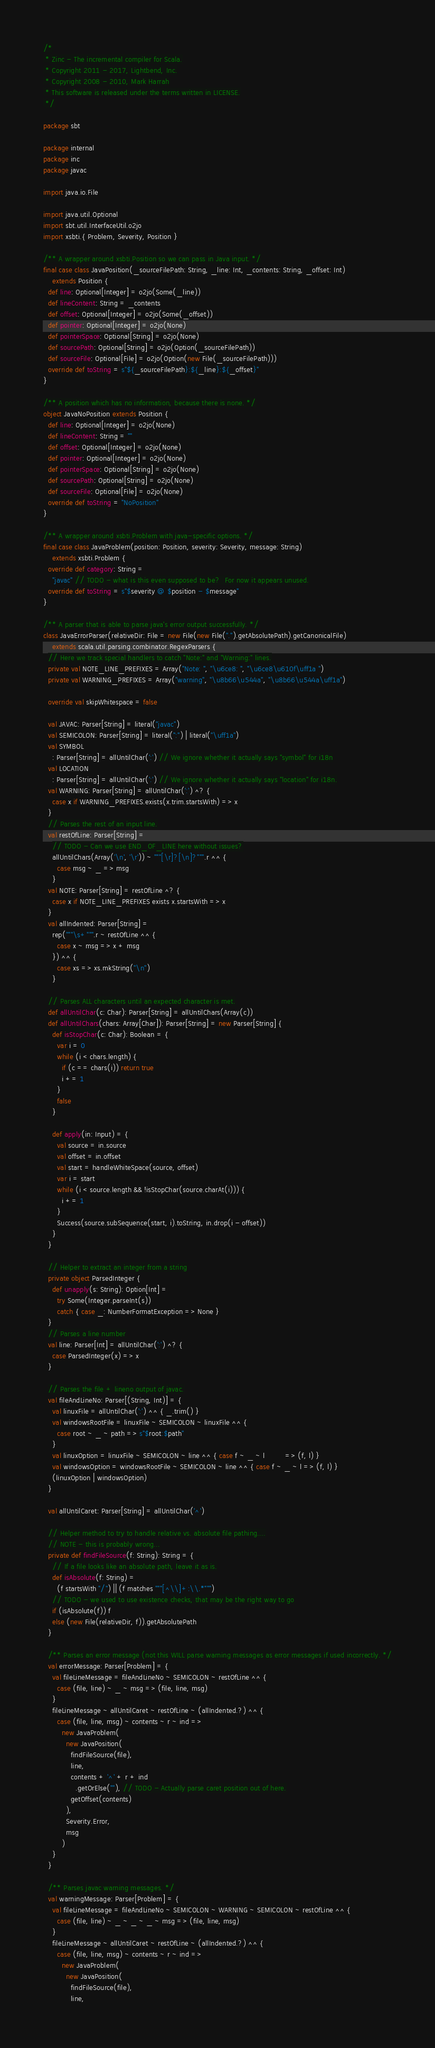<code> <loc_0><loc_0><loc_500><loc_500><_Scala_>/*
 * Zinc - The incremental compiler for Scala.
 * Copyright 2011 - 2017, Lightbend, Inc.
 * Copyright 2008 - 2010, Mark Harrah
 * This software is released under the terms written in LICENSE.
 */

package sbt

package internal
package inc
package javac

import java.io.File

import java.util.Optional
import sbt.util.InterfaceUtil.o2jo
import xsbti.{ Problem, Severity, Position }

/** A wrapper around xsbti.Position so we can pass in Java input. */
final case class JavaPosition(_sourceFilePath: String, _line: Int, _contents: String, _offset: Int)
    extends Position {
  def line: Optional[Integer] = o2jo(Some(_line))
  def lineContent: String = _contents
  def offset: Optional[Integer] = o2jo(Some(_offset))
  def pointer: Optional[Integer] = o2jo(None)
  def pointerSpace: Optional[String] = o2jo(None)
  def sourcePath: Optional[String] = o2jo(Option(_sourceFilePath))
  def sourceFile: Optional[File] = o2jo(Option(new File(_sourceFilePath)))
  override def toString = s"${_sourceFilePath}:${_line}:${_offset}"
}

/** A position which has no information, because there is none. */
object JavaNoPosition extends Position {
  def line: Optional[Integer] = o2jo(None)
  def lineContent: String = ""
  def offset: Optional[Integer] = o2jo(None)
  def pointer: Optional[Integer] = o2jo(None)
  def pointerSpace: Optional[String] = o2jo(None)
  def sourcePath: Optional[String] = o2jo(None)
  def sourceFile: Optional[File] = o2jo(None)
  override def toString = "NoPosition"
}

/** A wrapper around xsbti.Problem with java-specific options. */
final case class JavaProblem(position: Position, severity: Severity, message: String)
    extends xsbti.Problem {
  override def category: String =
    "javac" // TODO - what is this even supposed to be?  For now it appears unused.
  override def toString = s"$severity @ $position - $message"
}

/** A parser that is able to parse java's error output successfully. */
class JavaErrorParser(relativeDir: File = new File(new File(".").getAbsolutePath).getCanonicalFile)
    extends scala.util.parsing.combinator.RegexParsers {
  // Here we track special handlers to catch "Note:" and "Warning:" lines.
  private val NOTE_LINE_PREFIXES = Array("Note: ", "\u6ce8: ", "\u6ce8\u610f\uff1a ")
  private val WARNING_PREFIXES = Array("warning", "\u8b66\u544a", "\u8b66\u544a\uff1a")

  override val skipWhitespace = false

  val JAVAC: Parser[String] = literal("javac")
  val SEMICOLON: Parser[String] = literal(":") | literal("\uff1a")
  val SYMBOL
    : Parser[String] = allUntilChar(':') // We ignore whether it actually says "symbol" for i18n
  val LOCATION
    : Parser[String] = allUntilChar(':') // We ignore whether it actually says "location" for i18n.
  val WARNING: Parser[String] = allUntilChar(':') ^? {
    case x if WARNING_PREFIXES.exists(x.trim.startsWith) => x
  }
  // Parses the rest of an input line.
  val restOfLine: Parser[String] =
    // TODO - Can we use END_OF_LINE here without issues?
    allUntilChars(Array('\n', '\r')) ~ """[\r]?[\n]?""".r ^^ {
      case msg ~ _ => msg
    }
  val NOTE: Parser[String] = restOfLine ^? {
    case x if NOTE_LINE_PREFIXES exists x.startsWith => x
  }
  val allIndented: Parser[String] =
    rep("""\s+""".r ~ restOfLine ^^ {
      case x ~ msg => x + msg
    }) ^^ {
      case xs => xs.mkString("\n")
    }

  // Parses ALL characters until an expected character is met.
  def allUntilChar(c: Char): Parser[String] = allUntilChars(Array(c))
  def allUntilChars(chars: Array[Char]): Parser[String] = new Parser[String] {
    def isStopChar(c: Char): Boolean = {
      var i = 0
      while (i < chars.length) {
        if (c == chars(i)) return true
        i += 1
      }
      false
    }

    def apply(in: Input) = {
      val source = in.source
      val offset = in.offset
      val start = handleWhiteSpace(source, offset)
      var i = start
      while (i < source.length && !isStopChar(source.charAt(i))) {
        i += 1
      }
      Success(source.subSequence(start, i).toString, in.drop(i - offset))
    }
  }

  // Helper to extract an integer from a string
  private object ParsedInteger {
    def unapply(s: String): Option[Int] =
      try Some(Integer.parseInt(s))
      catch { case _: NumberFormatException => None }
  }
  // Parses a line number
  val line: Parser[Int] = allUntilChar(':') ^? {
    case ParsedInteger(x) => x
  }

  // Parses the file + lineno output of javac.
  val fileAndLineNo: Parser[(String, Int)] = {
    val linuxFile = allUntilChar(':') ^^ { _.trim() }
    val windowsRootFile = linuxFile ~ SEMICOLON ~ linuxFile ^^ {
      case root ~ _ ~ path => s"$root:$path"
    }
    val linuxOption = linuxFile ~ SEMICOLON ~ line ^^ { case f ~ _ ~ l         => (f, l) }
    val windowsOption = windowsRootFile ~ SEMICOLON ~ line ^^ { case f ~ _ ~ l => (f, l) }
    (linuxOption | windowsOption)
  }

  val allUntilCaret: Parser[String] = allUntilChar('^')

  // Helper method to try to handle relative vs. absolute file pathing....
  // NOTE - this is probably wrong...
  private def findFileSource(f: String): String = {
    // If a file looks like an absolute path, leave it as is.
    def isAbsolute(f: String) =
      (f startsWith "/") || (f matches """[^\\]+:\\.*""")
    // TODO - we used to use existence checks, that may be the right way to go
    if (isAbsolute(f)) f
    else (new File(relativeDir, f)).getAbsolutePath
  }

  /** Parses an error message (not this WILL parse warning messages as error messages if used incorrectly. */
  val errorMessage: Parser[Problem] = {
    val fileLineMessage = fileAndLineNo ~ SEMICOLON ~ restOfLine ^^ {
      case (file, line) ~ _ ~ msg => (file, line, msg)
    }
    fileLineMessage ~ allUntilCaret ~ restOfLine ~ (allIndented.?) ^^ {
      case (file, line, msg) ~ contents ~ r ~ ind =>
        new JavaProblem(
          new JavaPosition(
            findFileSource(file),
            line,
            contents + '^' + r + ind
              .getOrElse(""), // TODO - Actually parse caret position out of here.
            getOffset(contents)
          ),
          Severity.Error,
          msg
        )
    }
  }

  /** Parses javac warning messages. */
  val warningMessage: Parser[Problem] = {
    val fileLineMessage = fileAndLineNo ~ SEMICOLON ~ WARNING ~ SEMICOLON ~ restOfLine ^^ {
      case (file, line) ~ _ ~ _ ~ _ ~ msg => (file, line, msg)
    }
    fileLineMessage ~ allUntilCaret ~ restOfLine ~ (allIndented.?) ^^ {
      case (file, line, msg) ~ contents ~ r ~ ind =>
        new JavaProblem(
          new JavaPosition(
            findFileSource(file),
            line,</code> 